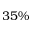Convert formula to latex. <formula><loc_0><loc_0><loc_500><loc_500>3 5 \%</formula> 